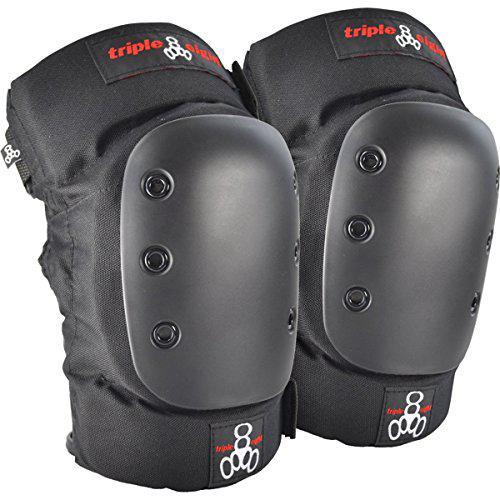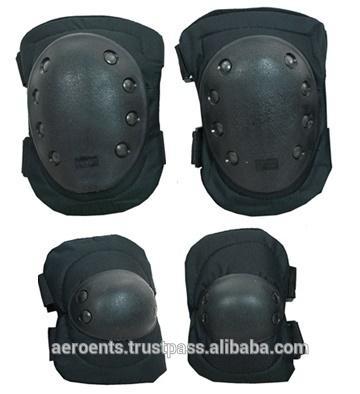The first image is the image on the left, the second image is the image on the right. Evaluate the accuracy of this statement regarding the images: "There are two kneepads with solid red writing across the top of the knee pad.". Is it true? Answer yes or no. Yes. 